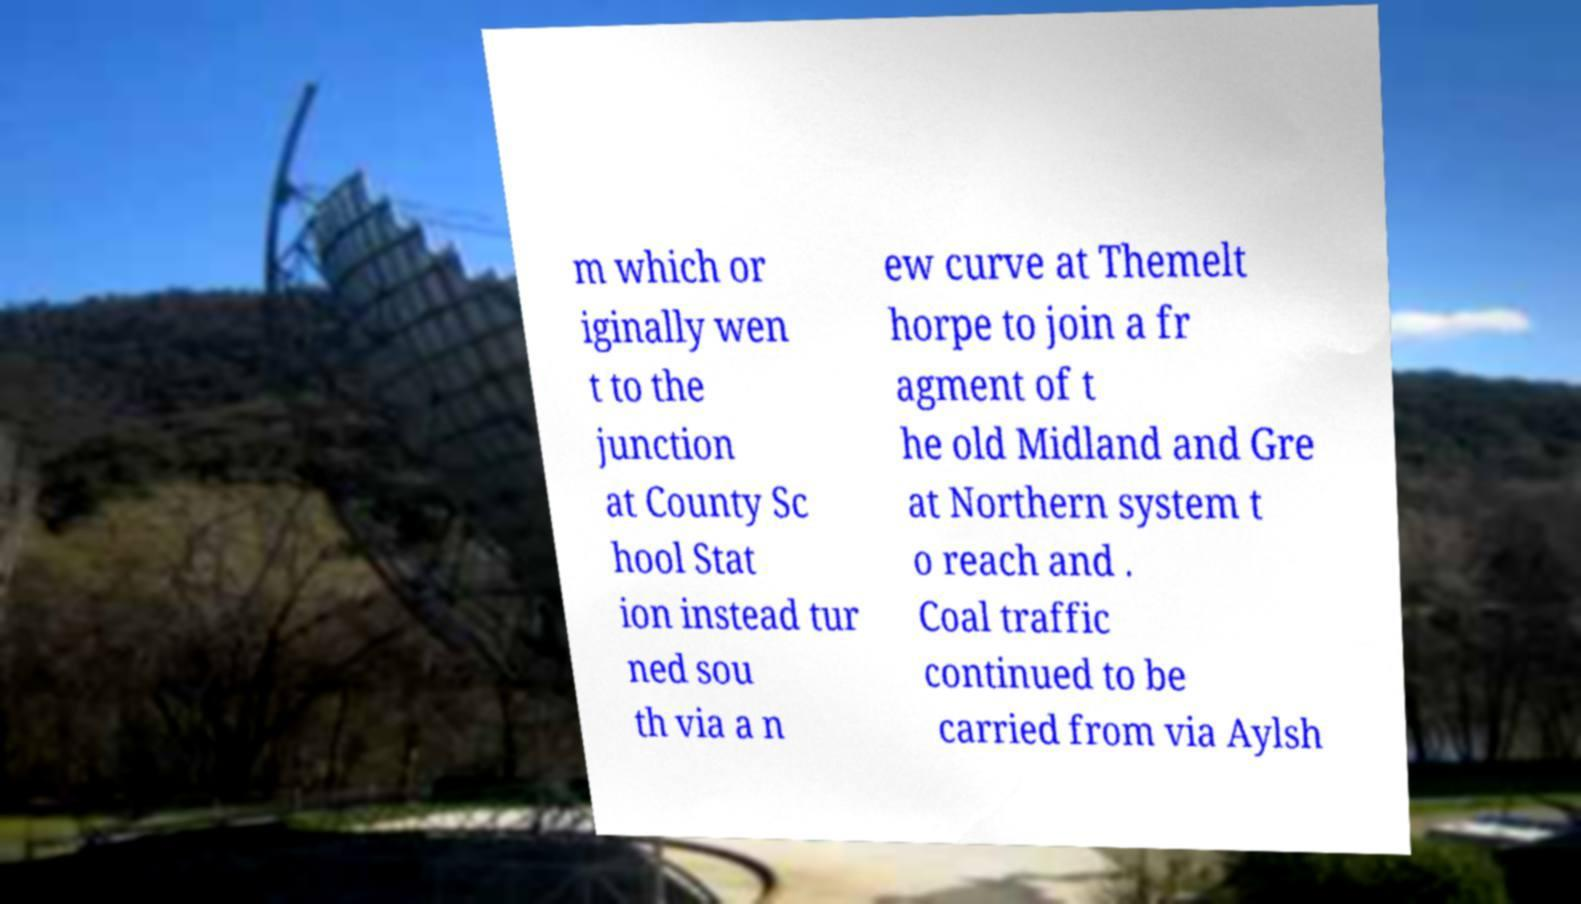Please identify and transcribe the text found in this image. m which or iginally wen t to the junction at County Sc hool Stat ion instead tur ned sou th via a n ew curve at Themelt horpe to join a fr agment of t he old Midland and Gre at Northern system t o reach and . Coal traffic continued to be carried from via Aylsh 